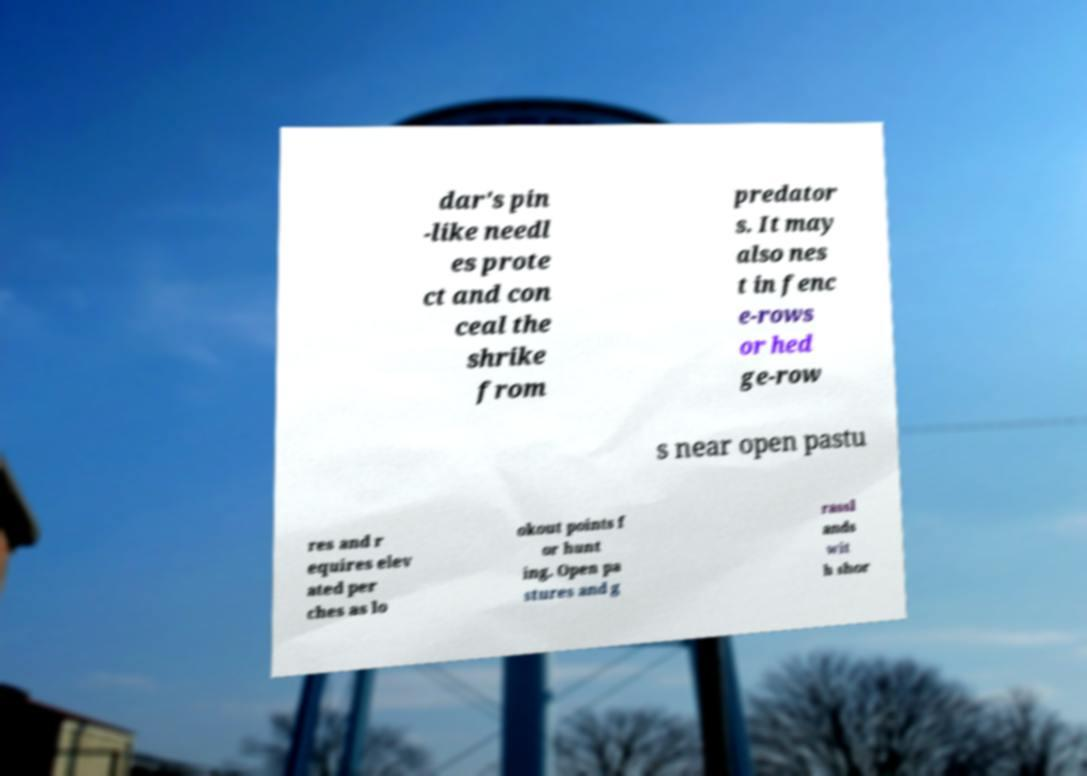I need the written content from this picture converted into text. Can you do that? dar's pin -like needl es prote ct and con ceal the shrike from predator s. It may also nes t in fenc e-rows or hed ge-row s near open pastu res and r equires elev ated per ches as lo okout points f or hunt ing. Open pa stures and g rassl ands wit h shor 